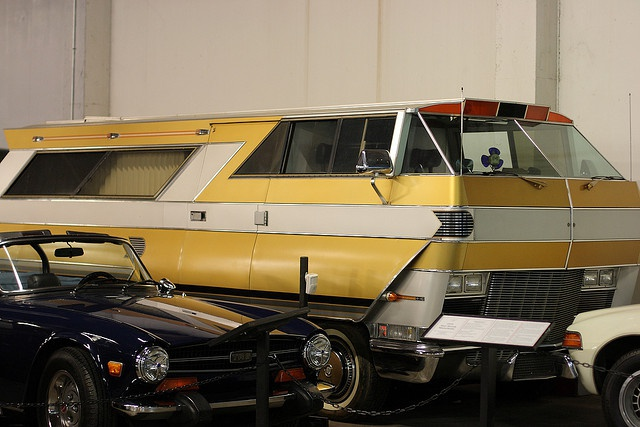Describe the objects in this image and their specific colors. I can see bus in gray, black, tan, and olive tones, car in gray, black, olive, and tan tones, and car in gray, black, and tan tones in this image. 